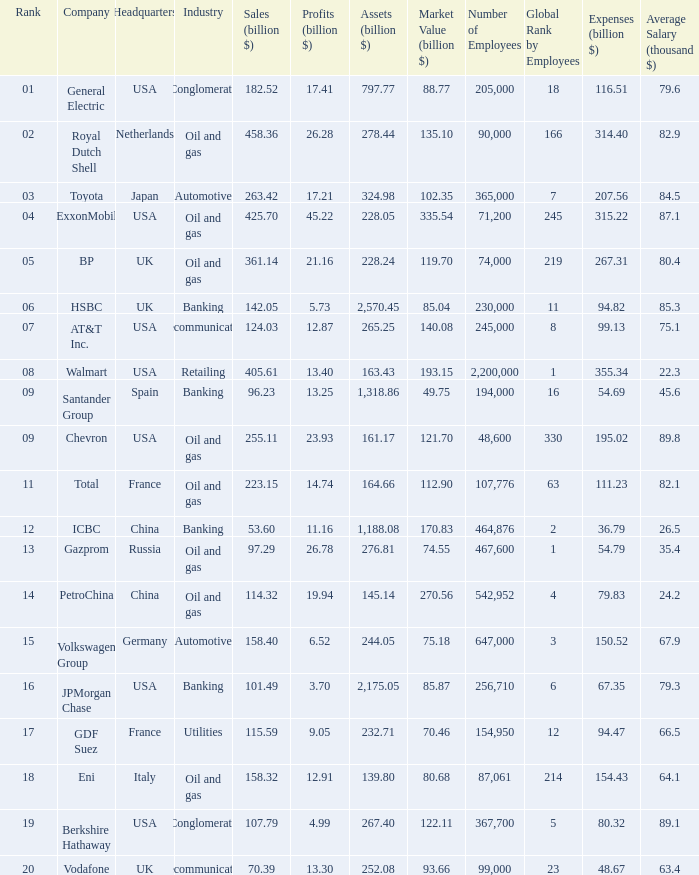Name the lowest Profits (billion $) which has a Sales (billion $) of 425.7, and a Rank larger than 4? None. 